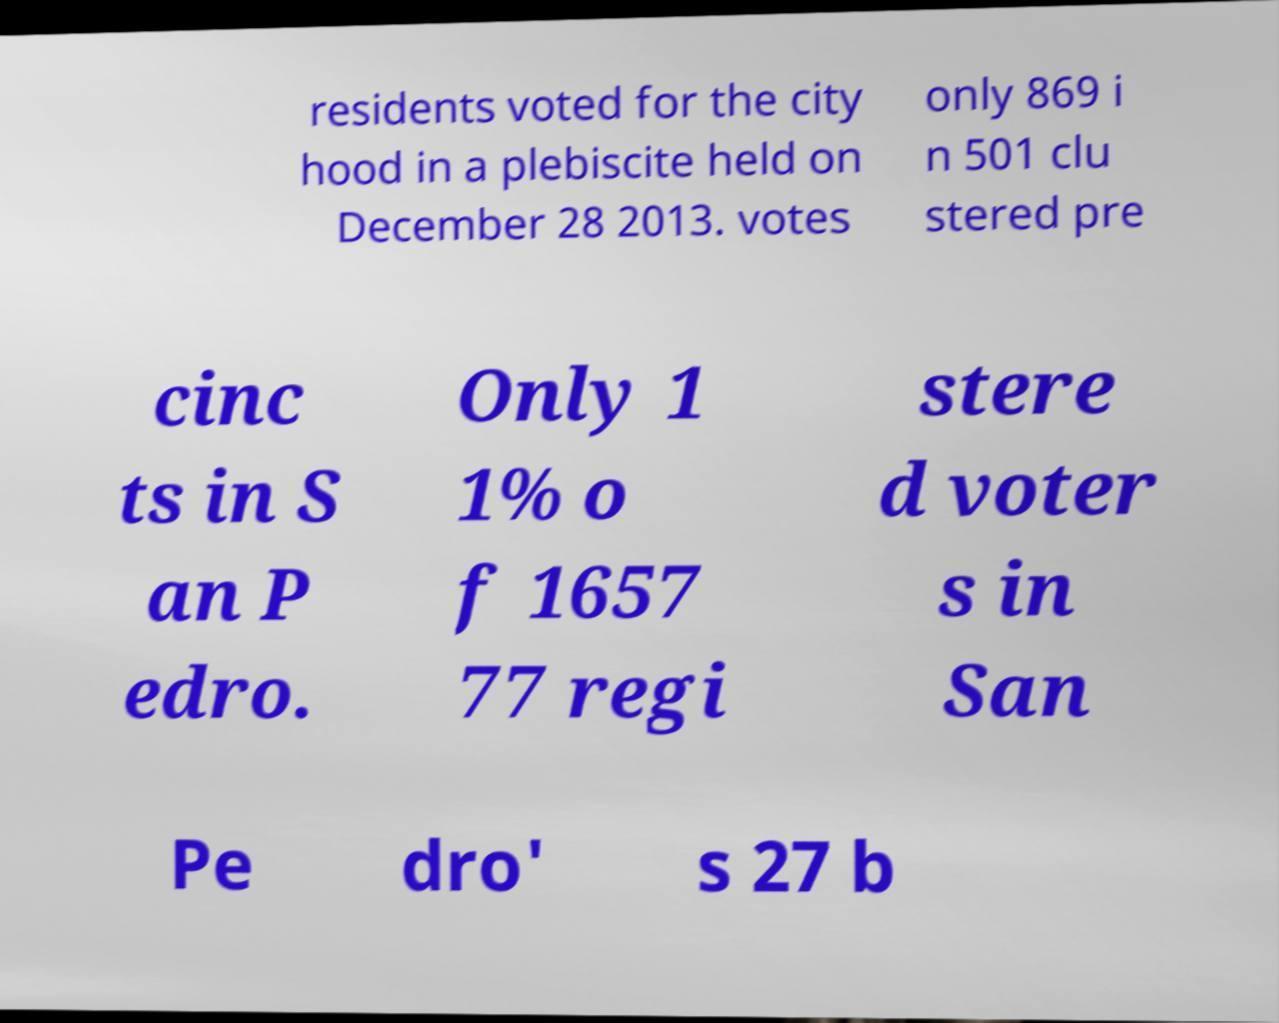Could you extract and type out the text from this image? residents voted for the city hood in a plebiscite held on December 28 2013. votes only 869 i n 501 clu stered pre cinc ts in S an P edro. Only 1 1% o f 1657 77 regi stere d voter s in San Pe dro' s 27 b 